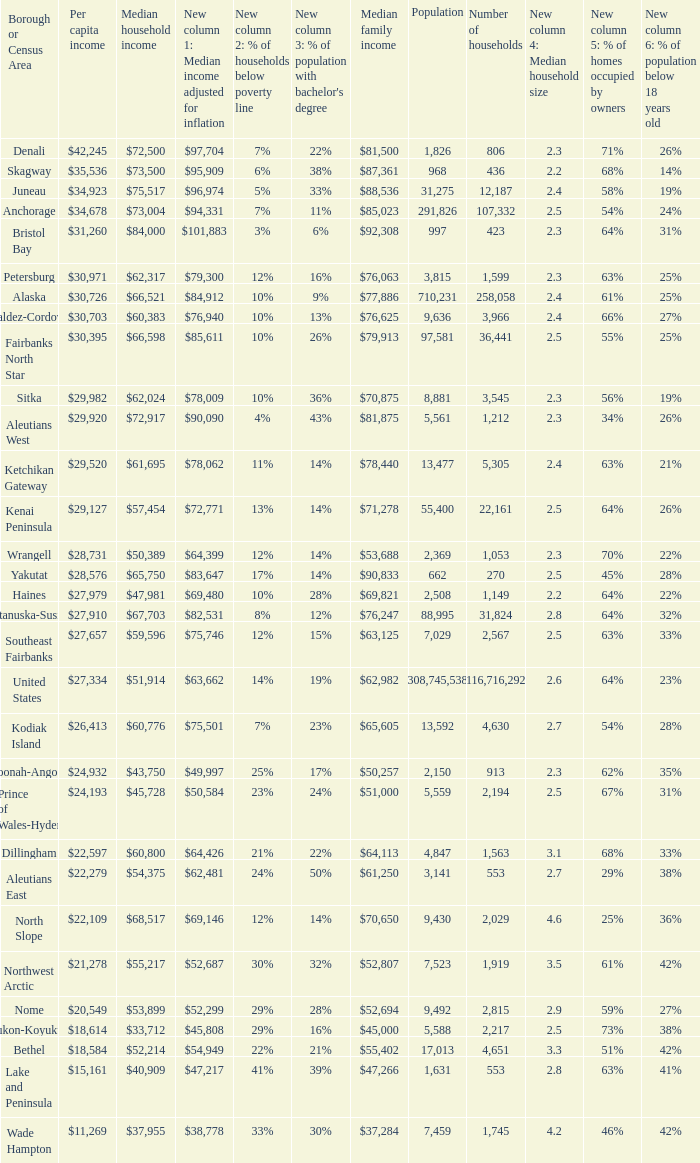Which borough or census area has a $59,596 median household income? Southeast Fairbanks. 